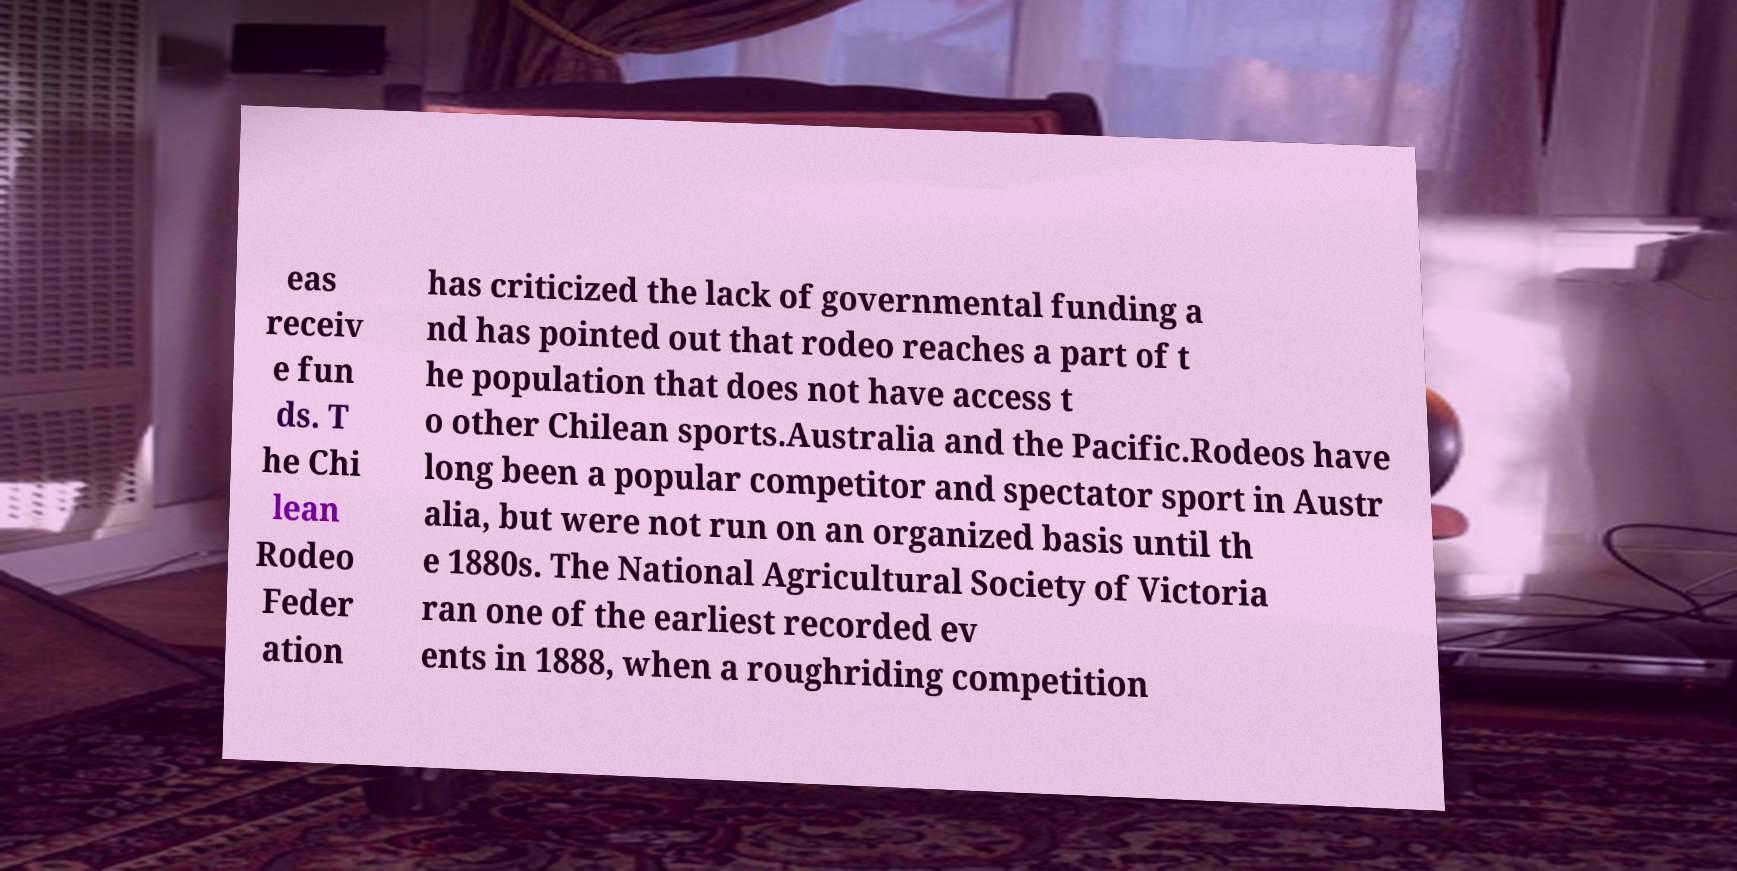There's text embedded in this image that I need extracted. Can you transcribe it verbatim? eas receiv e fun ds. T he Chi lean Rodeo Feder ation has criticized the lack of governmental funding a nd has pointed out that rodeo reaches a part of t he population that does not have access t o other Chilean sports.Australia and the Pacific.Rodeos have long been a popular competitor and spectator sport in Austr alia, but were not run on an organized basis until th e 1880s. The National Agricultural Society of Victoria ran one of the earliest recorded ev ents in 1888, when a roughriding competition 